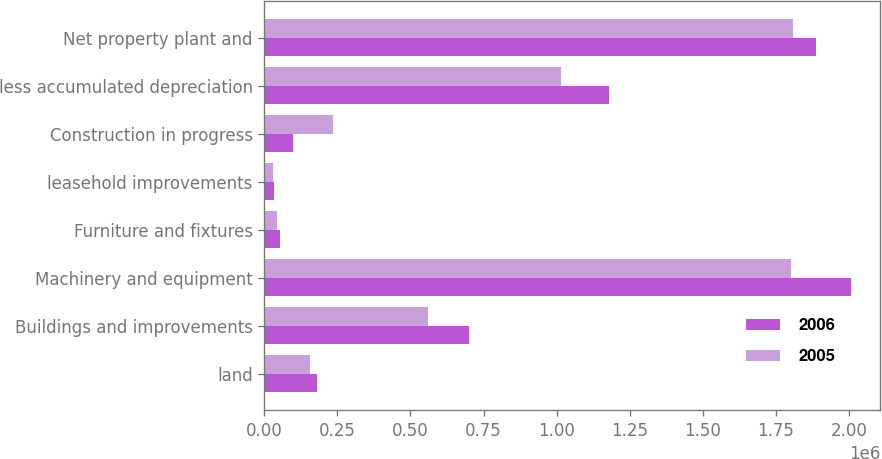Convert chart. <chart><loc_0><loc_0><loc_500><loc_500><stacked_bar_chart><ecel><fcel>land<fcel>Buildings and improvements<fcel>Machinery and equipment<fcel>Furniture and fixtures<fcel>leasehold improvements<fcel>Construction in progress<fcel>less accumulated depreciation<fcel>Net property plant and<nl><fcel>2006<fcel>178553<fcel>698878<fcel>2.00685e+06<fcel>53961<fcel>33702<fcel>96579<fcel>1.18043e+06<fcel>1.88809e+06<nl><fcel>2005<fcel>155670<fcel>559723<fcel>1.80237e+06<fcel>44765<fcel>28784<fcel>233525<fcel>1.01411e+06<fcel>1.81073e+06<nl></chart> 